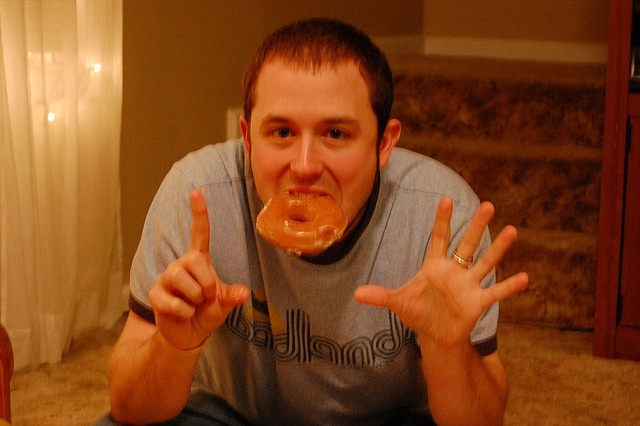Describe the objects in this image and their specific colors. I can see people in tan, maroon, red, and black tones and donut in tan, red, brown, and maroon tones in this image. 